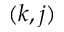Convert formula to latex. <formula><loc_0><loc_0><loc_500><loc_500>( k , j )</formula> 